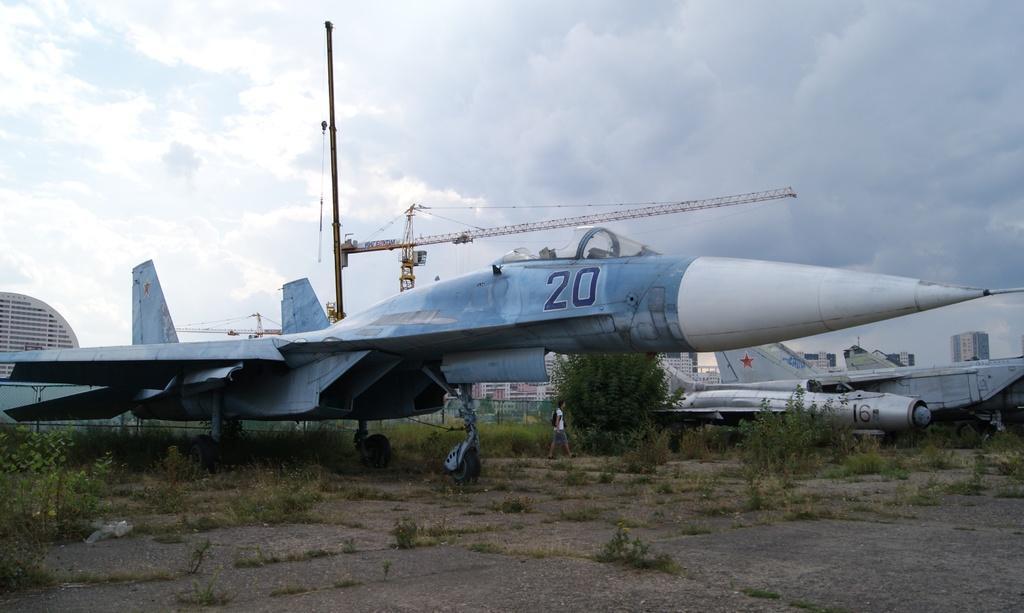Could you give a brief overview of what you see in this image? In this picture we can see few fighter jets, and a person is walking beside to the jet, in the background we can find few trees, fence, buildings and cranes. 